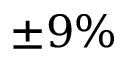<formula> <loc_0><loc_0><loc_500><loc_500>\pm 9 \%</formula> 